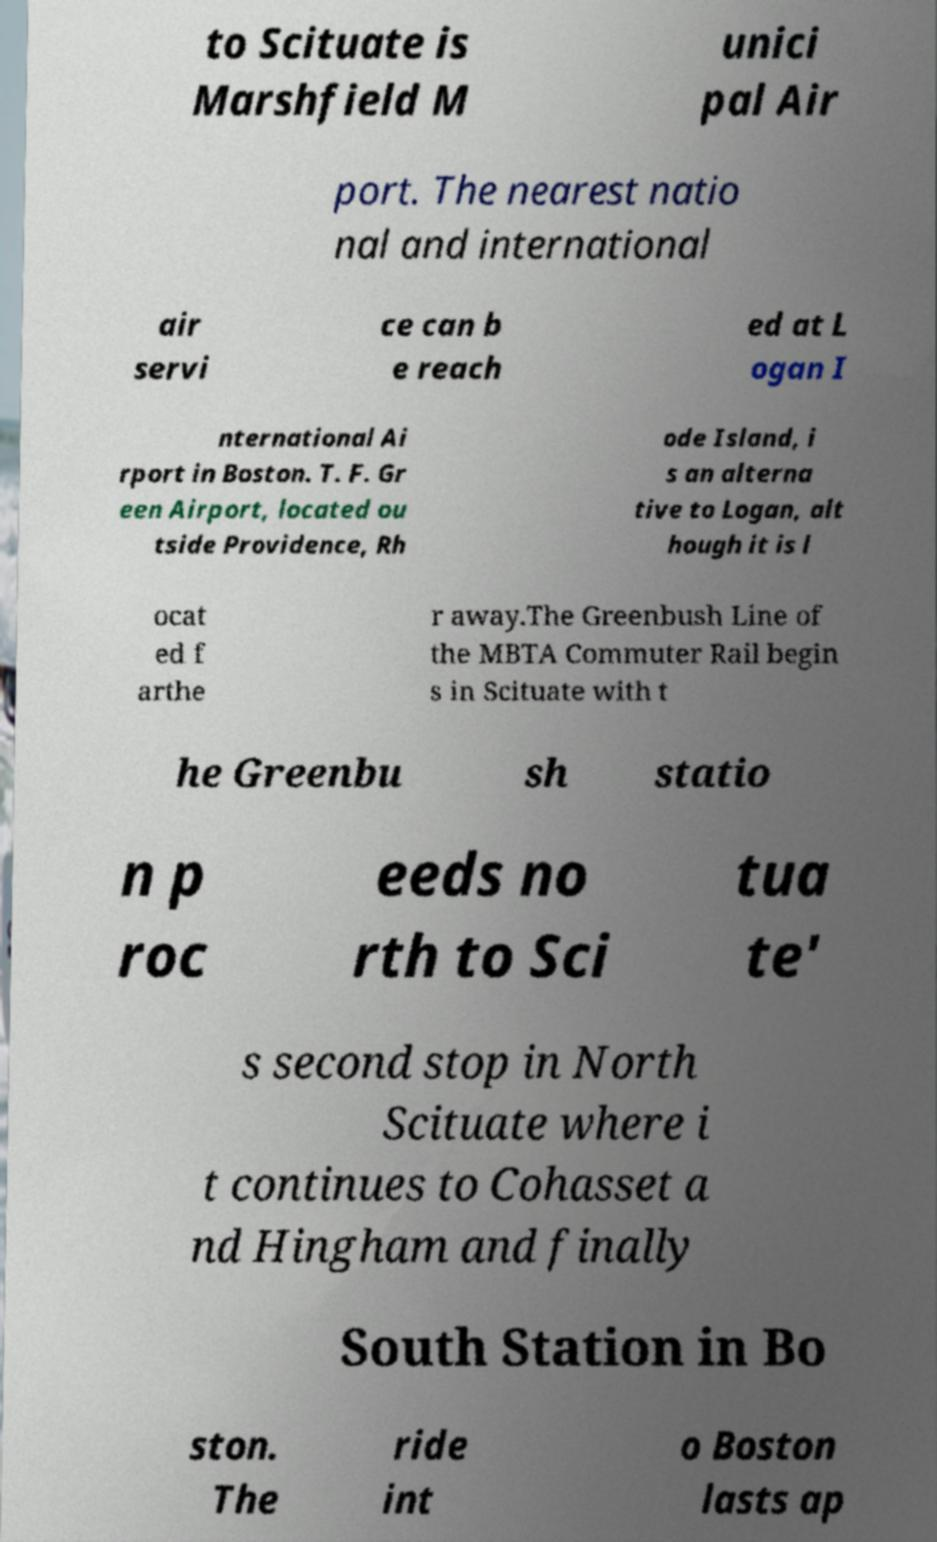Could you assist in decoding the text presented in this image and type it out clearly? to Scituate is Marshfield M unici pal Air port. The nearest natio nal and international air servi ce can b e reach ed at L ogan I nternational Ai rport in Boston. T. F. Gr een Airport, located ou tside Providence, Rh ode Island, i s an alterna tive to Logan, alt hough it is l ocat ed f arthe r away.The Greenbush Line of the MBTA Commuter Rail begin s in Scituate with t he Greenbu sh statio n p roc eeds no rth to Sci tua te' s second stop in North Scituate where i t continues to Cohasset a nd Hingham and finally South Station in Bo ston. The ride int o Boston lasts ap 